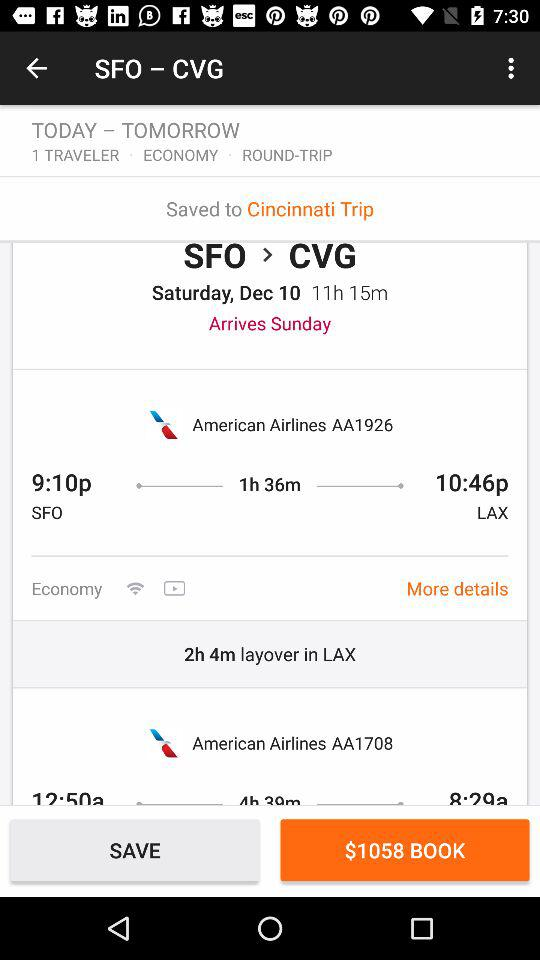What is the total price of this flight?
Answer the question using a single word or phrase. $1058 